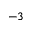Convert formula to latex. <formula><loc_0><loc_0><loc_500><loc_500>^ { - 3 }</formula> 